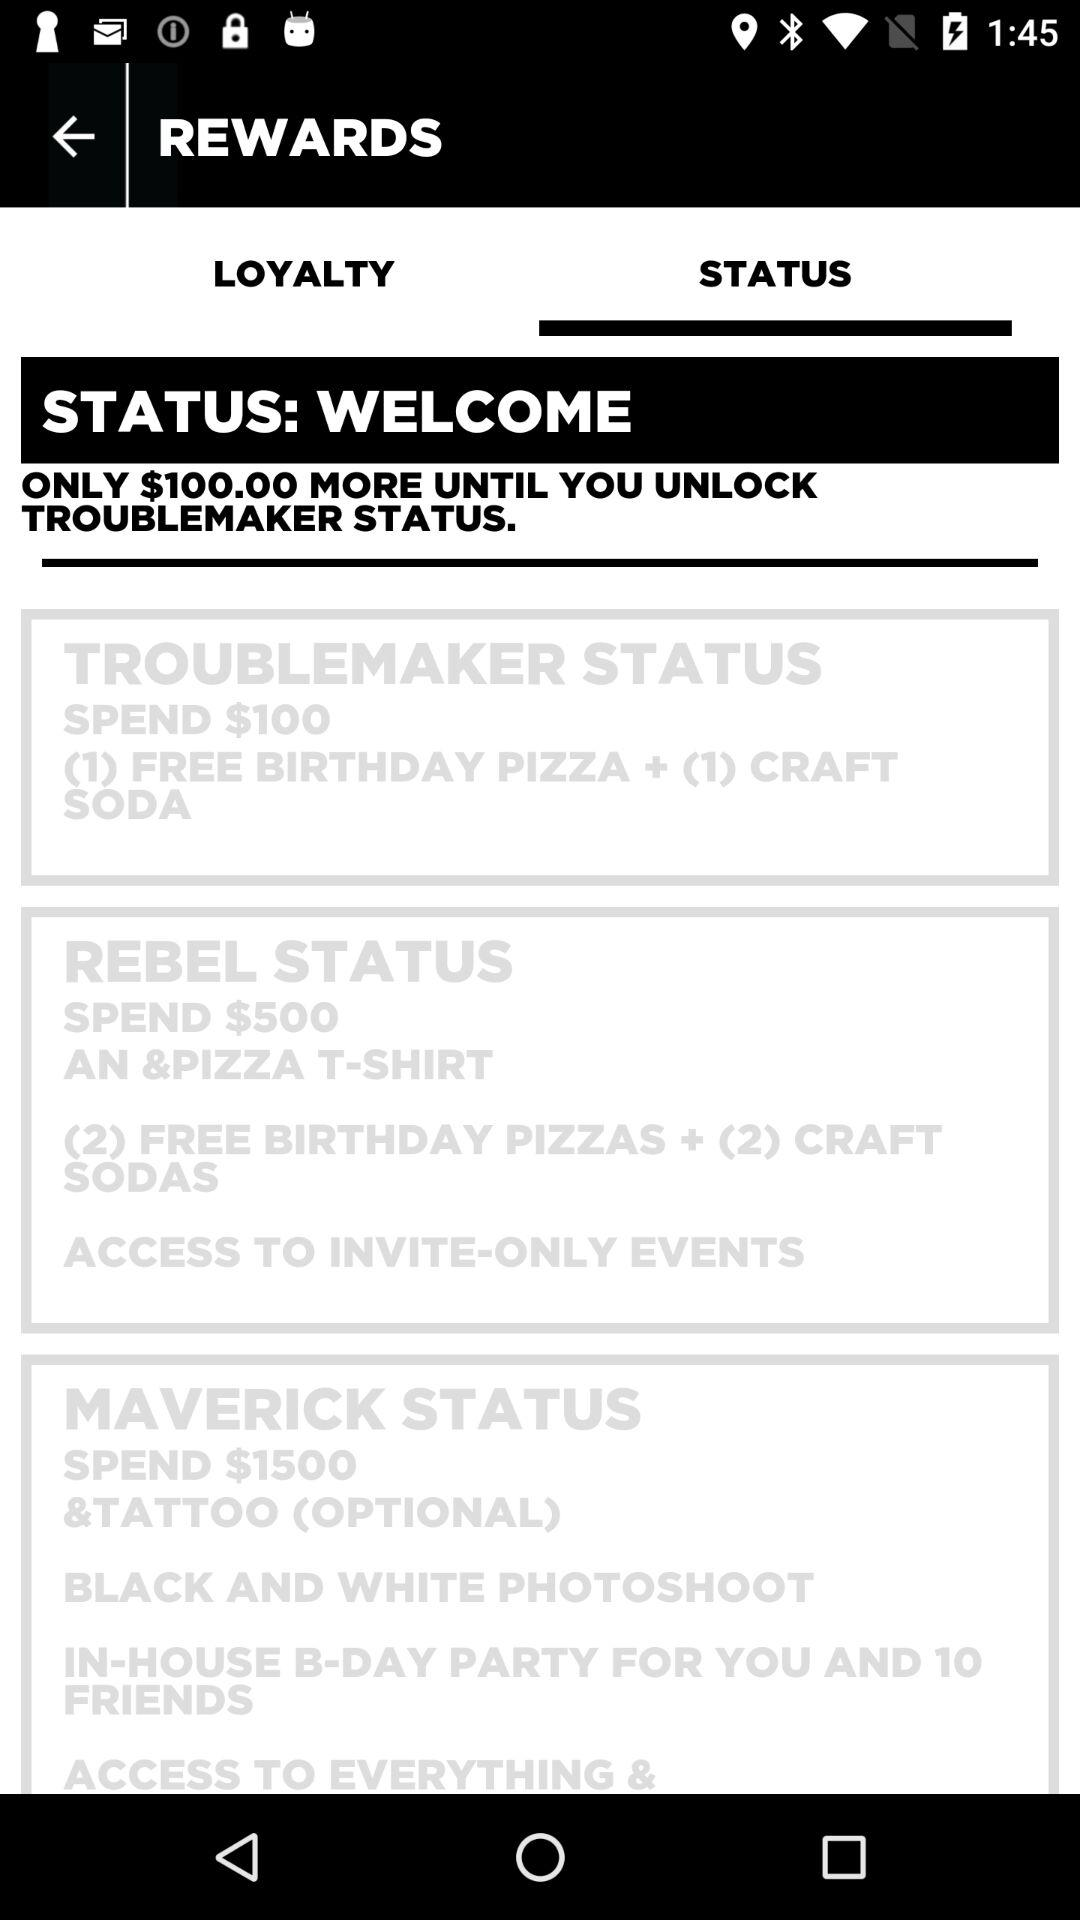How much more do I need to spend to reach Troublemaker status?
Answer the question using a single word or phrase. $100.00 